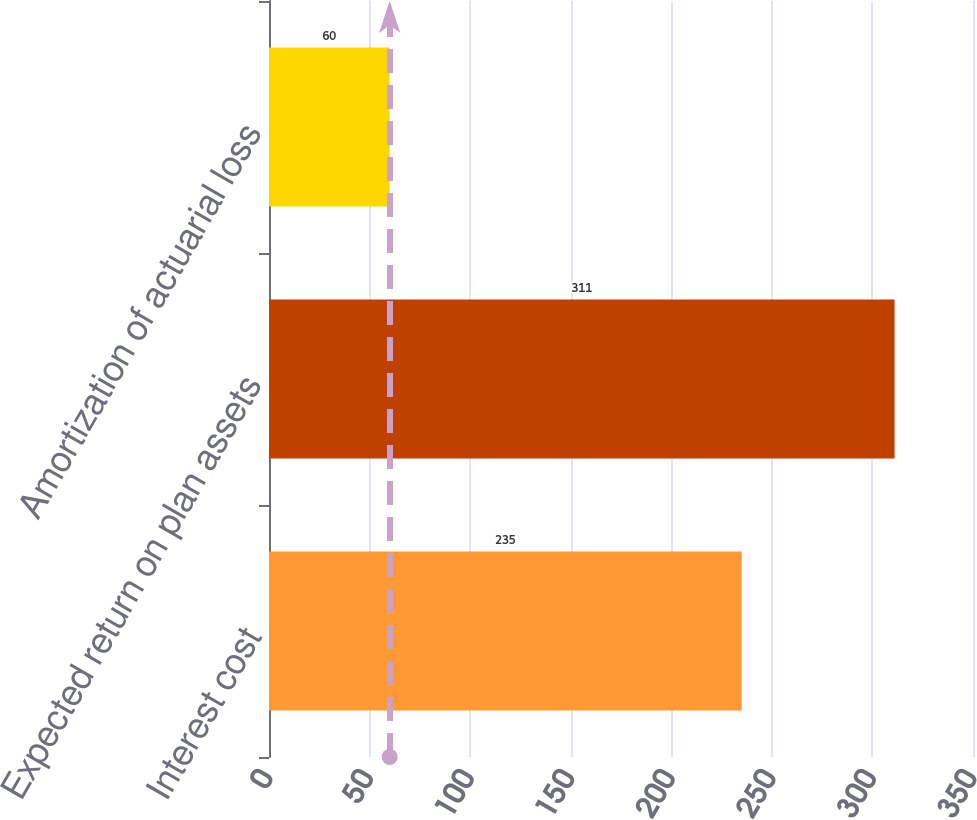<chart> <loc_0><loc_0><loc_500><loc_500><bar_chart><fcel>Interest cost<fcel>Expected return on plan assets<fcel>Amortization of actuarial loss<nl><fcel>235<fcel>311<fcel>60<nl></chart> 